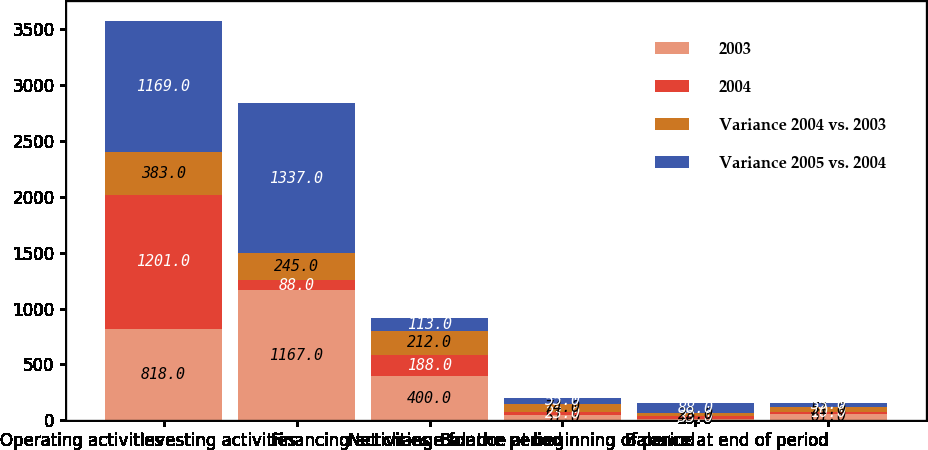Convert chart. <chart><loc_0><loc_0><loc_500><loc_500><stacked_bar_chart><ecel><fcel>Operating activities<fcel>Investing activities<fcel>Financing activities<fcel>Net change for the period<fcel>Balance at beginning of period<fcel>Balance at end of period<nl><fcel>2003<fcel>818<fcel>1167<fcel>400<fcel>51<fcel>10<fcel>61<nl><fcel>2004<fcel>1201<fcel>88<fcel>188<fcel>23<fcel>33<fcel>10<nl><fcel>Variance 2004 vs. 2003<fcel>383<fcel>245<fcel>212<fcel>74<fcel>23<fcel>51<nl><fcel>Variance 2005 vs. 2004<fcel>1169<fcel>1337<fcel>113<fcel>55<fcel>88<fcel>33<nl></chart> 